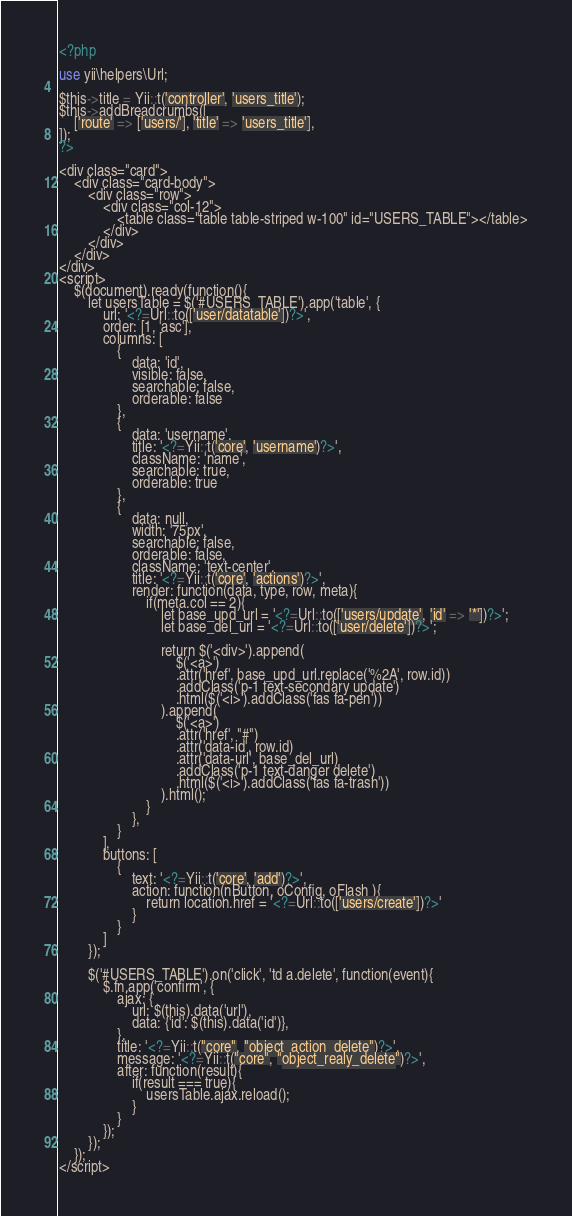Convert code to text. <code><loc_0><loc_0><loc_500><loc_500><_PHP_><?php

use yii\helpers\Url;

$this->title = Yii::t('controller', 'users_title');
$this->addBreadcrumbs([
    ['route' => ['users/'], 'title' => 'users_title'],
]);
?>

<div class="card">
	<div class="card-body">
		<div class="row">
			<div class="col-12">
				<table class="table table-striped w-100" id="USERS_TABLE"></table>
			</div>
		</div>
	</div>
</div>
<script>
	$(document).ready(function(){
		let usersTable = $('#USERS_TABLE').app('table', {
			url: '<?=Url::to(['user/datatable'])?>',
			order: [1, 'asc'],
			columns: [
				{
					data: 'id',
					visible: false,
					searchable: false,
					orderable: false
				},
				{
					data: 'username',
					title: '<?=Yii::t('core', 'username')?>',
					className: 'name',
					searchable: true,
					orderable: true
				},
				{
					data: null,
					width: '75px',
					searchable: false,
					orderable: false,
					className: 'text-center',
					title: '<?=Yii::t('core', 'actions')?>',
					render: function(data, type, row, meta){
						if(meta.col == 2){
							let base_upd_url = '<?=Url::to(['users/update', 'id' => '*'])?>';
							let base_del_url = '<?=Url::to(['user/delete'])?>';

							return $('<div>').append(
								$('<a>')
								.attr('href', base_upd_url.replace('%2A', row.id))
								.addClass('p-1 text-secondary update')
								.html($('<i>').addClass('fas fa-pen'))
							).append(
								$('<a>')
								.attr('href', "#")
								.attr('data-id', row.id)
								.attr('data-url', base_del_url)
								.addClass('p-1 text-danger delete')
								.html($('<i>').addClass('fas fa-trash'))
							).html();
						}
					},
				}
			],
			buttons: [
				{
					text: '<?=Yii::t('core', 'add')?>',
					action: function(nButton, oConfig, oFlash ){
						return location.href = '<?=Url::to(['users/create'])?>'
					}
				}
			]
		});

		$('#USERS_TABLE').on('click', 'td a.delete', function(event){
			$.fn.app('confirm', {
				ajax: {
					url: $(this).data('url'),
					data: {'id': $(this).data('id')},
				},
				title: '<?=Yii::t("core", "object_action_delete")?>',
				message: '<?=Yii::t("core", "object_realy_delete")?>',
				after: function(result){
					if(result === true){
						usersTable.ajax.reload();
					}
				}
			});
		});
	});
</script></code> 